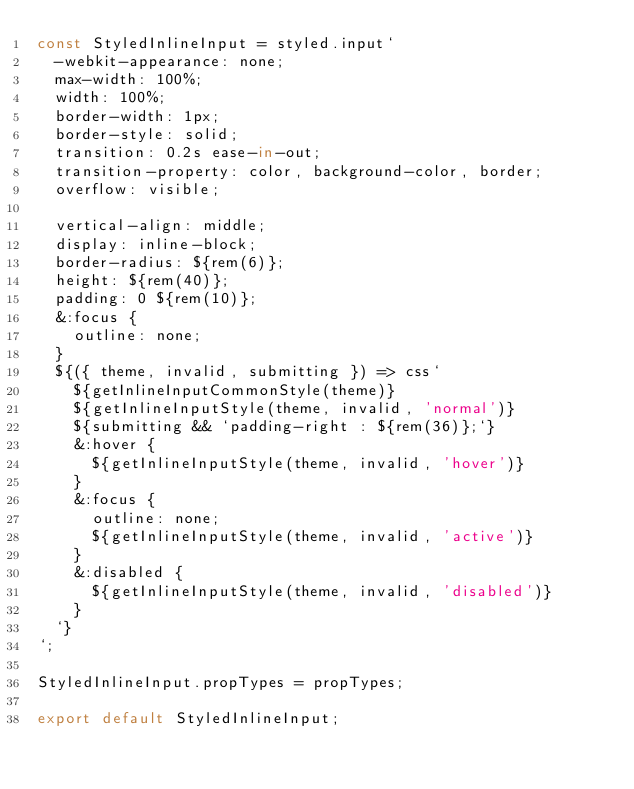<code> <loc_0><loc_0><loc_500><loc_500><_JavaScript_>const StyledInlineInput = styled.input`
  -webkit-appearance: none;
  max-width: 100%;
  width: 100%;
  border-width: 1px;
  border-style: solid;
  transition: 0.2s ease-in-out;
  transition-property: color, background-color, border;
  overflow: visible;

  vertical-align: middle;
  display: inline-block;
  border-radius: ${rem(6)};
  height: ${rem(40)};
  padding: 0 ${rem(10)};
  &:focus {
    outline: none;
  }
  ${({ theme, invalid, submitting }) => css`
    ${getInlineInputCommonStyle(theme)}
    ${getInlineInputStyle(theme, invalid, 'normal')}
    ${submitting && `padding-right : ${rem(36)};`}
    &:hover {
      ${getInlineInputStyle(theme, invalid, 'hover')}
    }
    &:focus {
      outline: none;
      ${getInlineInputStyle(theme, invalid, 'active')}
    }
    &:disabled {
      ${getInlineInputStyle(theme, invalid, 'disabled')}
    }
  `}
`;

StyledInlineInput.propTypes = propTypes;

export default StyledInlineInput;
</code> 